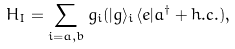<formula> <loc_0><loc_0><loc_500><loc_500>H _ { I } = \sum _ { i = a , b } g _ { i } ( | g \rangle _ { i } \langle e | a ^ { \dagger } + h . c . ) ,</formula> 